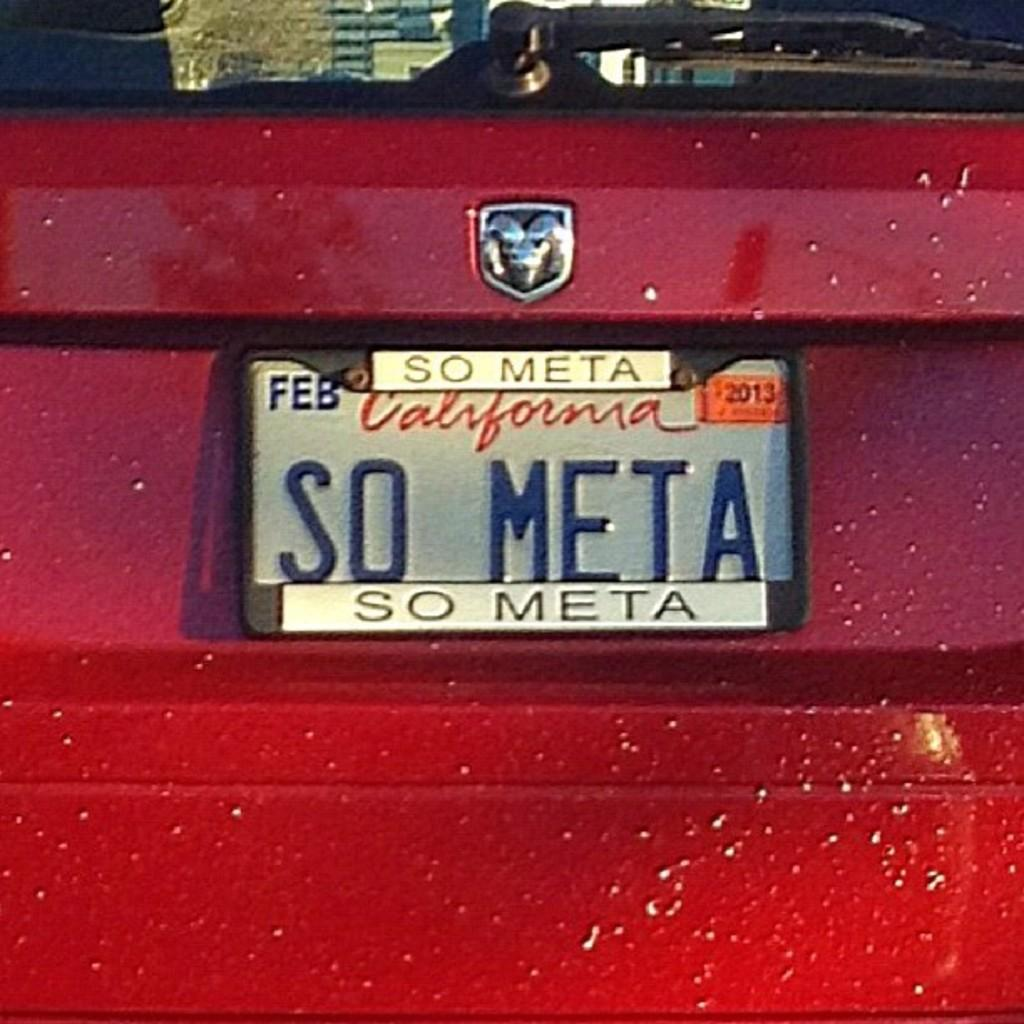What is the main subject of the image? The main subject of the image is a car. Can you describe the color of the car? The car is red. Is there any identifying information on the car? Yes, there is a registration plate on the car. What can be found on the registration plate? The registration plate has text on it. Are there any additional features on the car? Yes, there is a wiper on the back windshield of the car. Can you tell me how many ducks are swimming in the lake in the image? There is no lake or ducks present in the image; it features a red car with a registration plate and a wiper on the back windshield. 